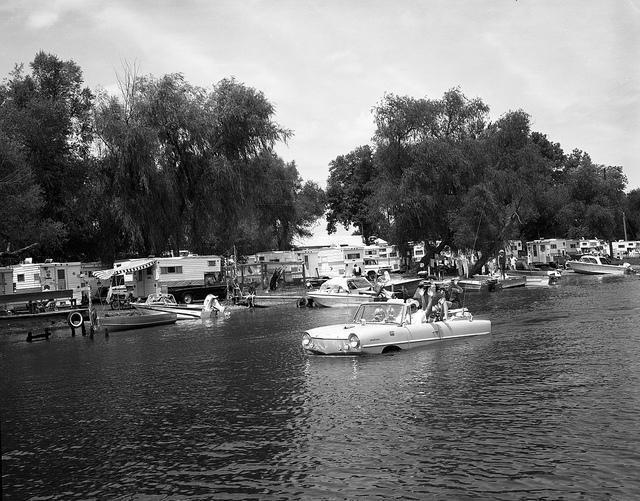How many toothbrushes do you see?
Give a very brief answer. 0. 